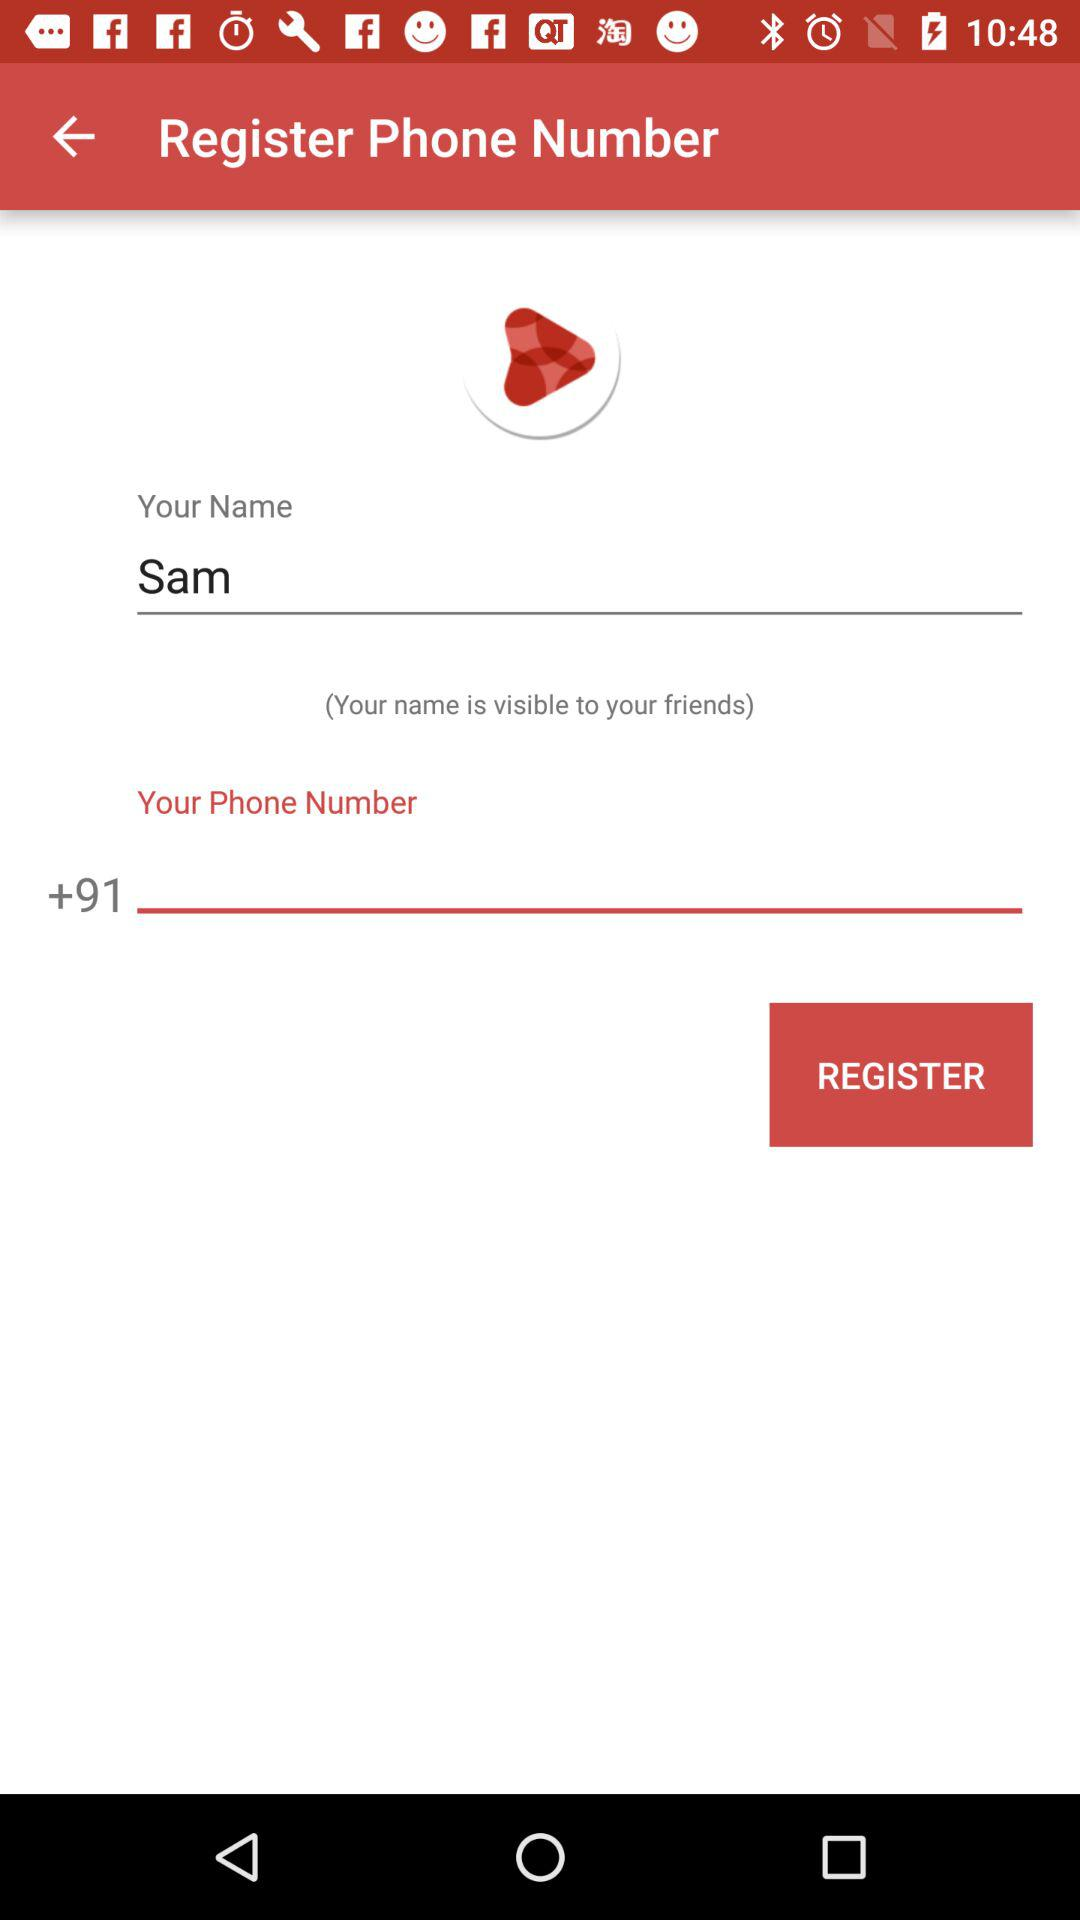What is the given user name? The given user name is Sam. 